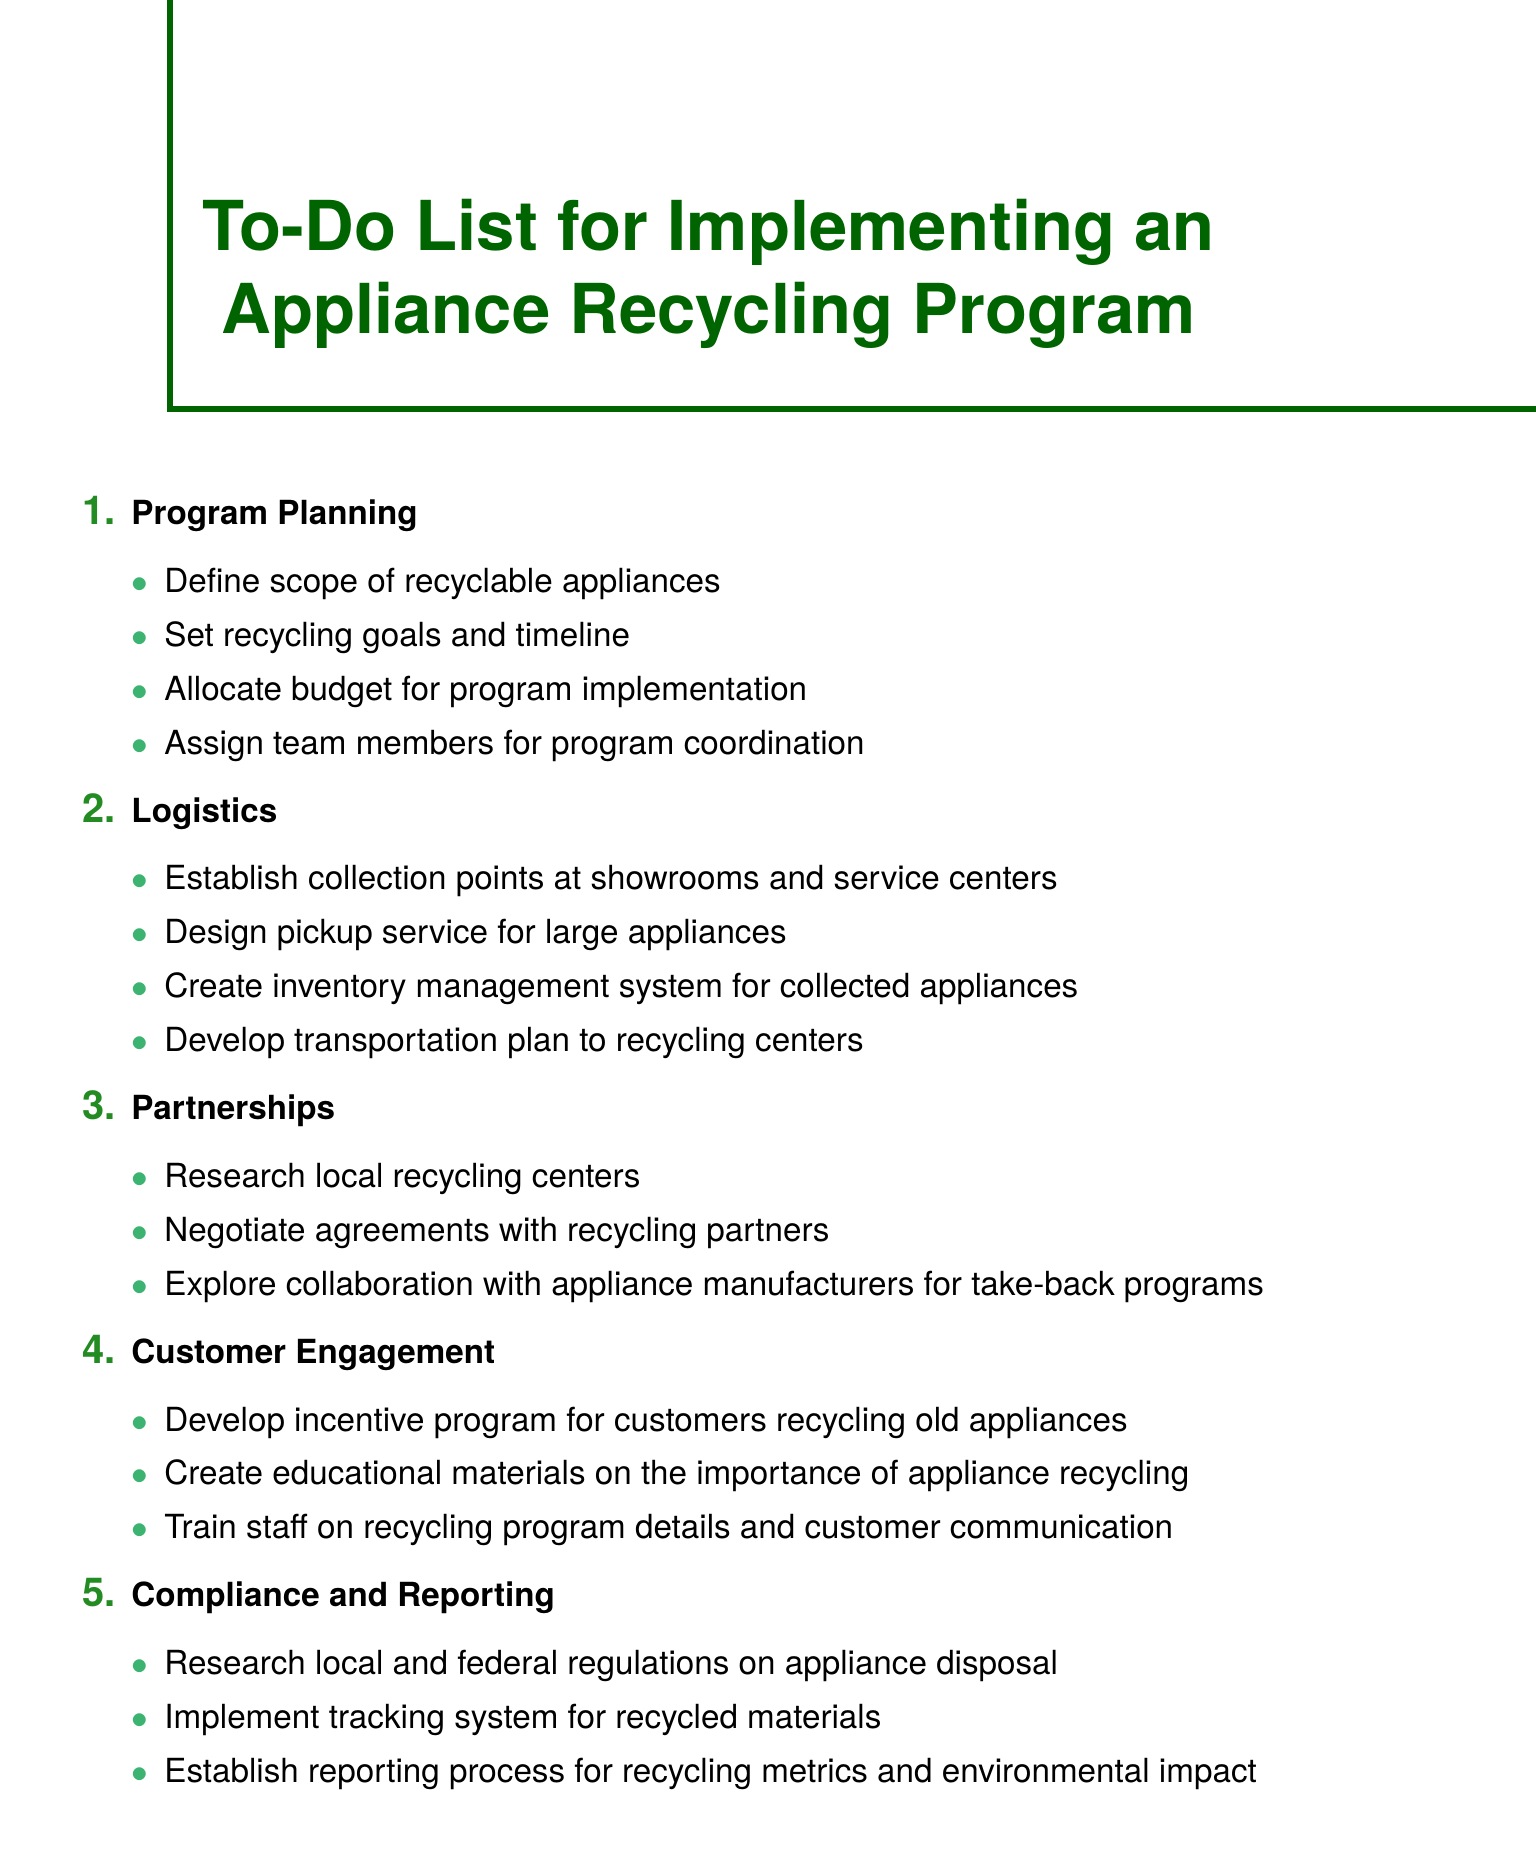what is the title of the document? The title of the document is stated at the beginning.
Answer: To-Do List for Implementing an Appliance Recycling Program how many sections are in the document? The number of sections is indicated by counting the main points listed.
Answer: 5 name one type of appliance defined for recycling. The document specifies the types of appliances included in the recycling program.
Answer: refrigerators what is one goal mentioned in the Program Planning section? Goals related to recycling are listed as part of the program planning focus.
Answer: Set recycling goals and timeline which item outlines a partnership exploration? The Contracts and Agreements item describes potential collaborations.
Answer: Explore collaboration with appliance manufacturers for take-back programs where should collection points be established? The logistics section details where to set up collection points for convenience.
Answer: showrooms and service centers what is being developed to engage customers? The Customer Engagement section mentions initiatives focused on involving customers in the recycling program.
Answer: Develop incentive program for customers recycling old appliances what type of regulations should be researched? The Compliance and Reporting section emphasizes the importance of adhering to regulations during the program.
Answer: local and federal regulations on appliance disposal what is one element of the logistics plan? The Logistics section specifies transportation and collection procedures necessary for the program's success.
Answer: Design pickup service for large appliances 